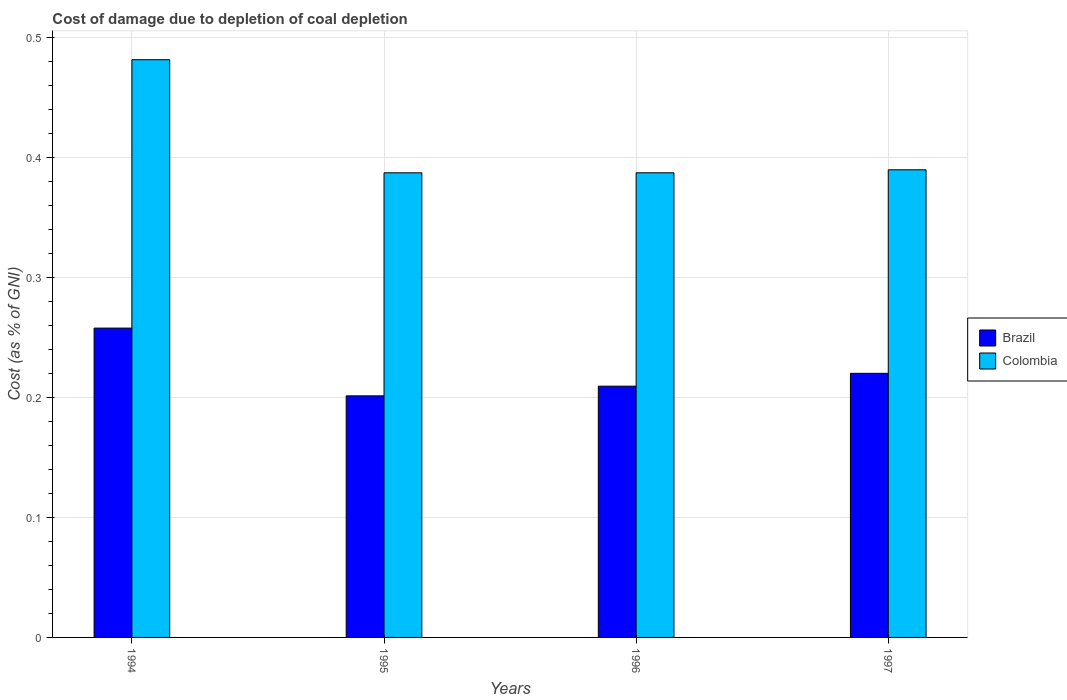How many groups of bars are there?
Your answer should be very brief. 4. Are the number of bars per tick equal to the number of legend labels?
Give a very brief answer. Yes. How many bars are there on the 4th tick from the left?
Provide a succinct answer. 2. How many bars are there on the 3rd tick from the right?
Provide a succinct answer. 2. What is the label of the 4th group of bars from the left?
Give a very brief answer. 1997. What is the cost of damage caused due to coal depletion in Colombia in 1995?
Your response must be concise. 0.39. Across all years, what is the maximum cost of damage caused due to coal depletion in Colombia?
Your answer should be very brief. 0.48. Across all years, what is the minimum cost of damage caused due to coal depletion in Brazil?
Give a very brief answer. 0.2. In which year was the cost of damage caused due to coal depletion in Colombia minimum?
Provide a short and direct response. 1995. What is the total cost of damage caused due to coal depletion in Colombia in the graph?
Keep it short and to the point. 1.65. What is the difference between the cost of damage caused due to coal depletion in Brazil in 1994 and that in 1995?
Keep it short and to the point. 0.06. What is the difference between the cost of damage caused due to coal depletion in Colombia in 1997 and the cost of damage caused due to coal depletion in Brazil in 1994?
Ensure brevity in your answer.  0.13. What is the average cost of damage caused due to coal depletion in Brazil per year?
Make the answer very short. 0.22. In the year 1994, what is the difference between the cost of damage caused due to coal depletion in Colombia and cost of damage caused due to coal depletion in Brazil?
Your answer should be very brief. 0.22. In how many years, is the cost of damage caused due to coal depletion in Brazil greater than 0.42000000000000004 %?
Offer a very short reply. 0. What is the ratio of the cost of damage caused due to coal depletion in Brazil in 1996 to that in 1997?
Keep it short and to the point. 0.95. Is the cost of damage caused due to coal depletion in Colombia in 1994 less than that in 1996?
Your answer should be very brief. No. What is the difference between the highest and the second highest cost of damage caused due to coal depletion in Brazil?
Make the answer very short. 0.04. What is the difference between the highest and the lowest cost of damage caused due to coal depletion in Brazil?
Your answer should be very brief. 0.06. In how many years, is the cost of damage caused due to coal depletion in Colombia greater than the average cost of damage caused due to coal depletion in Colombia taken over all years?
Provide a succinct answer. 1. Is the sum of the cost of damage caused due to coal depletion in Colombia in 1995 and 1997 greater than the maximum cost of damage caused due to coal depletion in Brazil across all years?
Give a very brief answer. Yes. How many bars are there?
Provide a short and direct response. 8. Are all the bars in the graph horizontal?
Offer a terse response. No. How many years are there in the graph?
Your answer should be very brief. 4. Are the values on the major ticks of Y-axis written in scientific E-notation?
Keep it short and to the point. No. Does the graph contain any zero values?
Ensure brevity in your answer.  No. Does the graph contain grids?
Your answer should be compact. Yes. What is the title of the graph?
Your answer should be compact. Cost of damage due to depletion of coal depletion. What is the label or title of the Y-axis?
Ensure brevity in your answer.  Cost (as % of GNI). What is the Cost (as % of GNI) of Brazil in 1994?
Your answer should be compact. 0.26. What is the Cost (as % of GNI) in Colombia in 1994?
Your response must be concise. 0.48. What is the Cost (as % of GNI) of Brazil in 1995?
Offer a terse response. 0.2. What is the Cost (as % of GNI) in Colombia in 1995?
Provide a short and direct response. 0.39. What is the Cost (as % of GNI) of Brazil in 1996?
Provide a short and direct response. 0.21. What is the Cost (as % of GNI) of Colombia in 1996?
Provide a short and direct response. 0.39. What is the Cost (as % of GNI) in Brazil in 1997?
Make the answer very short. 0.22. What is the Cost (as % of GNI) of Colombia in 1997?
Offer a very short reply. 0.39. Across all years, what is the maximum Cost (as % of GNI) of Brazil?
Provide a succinct answer. 0.26. Across all years, what is the maximum Cost (as % of GNI) of Colombia?
Give a very brief answer. 0.48. Across all years, what is the minimum Cost (as % of GNI) in Brazil?
Your response must be concise. 0.2. Across all years, what is the minimum Cost (as % of GNI) of Colombia?
Offer a terse response. 0.39. What is the total Cost (as % of GNI) in Brazil in the graph?
Offer a very short reply. 0.89. What is the total Cost (as % of GNI) in Colombia in the graph?
Keep it short and to the point. 1.65. What is the difference between the Cost (as % of GNI) in Brazil in 1994 and that in 1995?
Give a very brief answer. 0.06. What is the difference between the Cost (as % of GNI) of Colombia in 1994 and that in 1995?
Your answer should be compact. 0.09. What is the difference between the Cost (as % of GNI) of Brazil in 1994 and that in 1996?
Give a very brief answer. 0.05. What is the difference between the Cost (as % of GNI) of Colombia in 1994 and that in 1996?
Ensure brevity in your answer.  0.09. What is the difference between the Cost (as % of GNI) in Brazil in 1994 and that in 1997?
Give a very brief answer. 0.04. What is the difference between the Cost (as % of GNI) in Colombia in 1994 and that in 1997?
Offer a terse response. 0.09. What is the difference between the Cost (as % of GNI) in Brazil in 1995 and that in 1996?
Offer a terse response. -0.01. What is the difference between the Cost (as % of GNI) in Colombia in 1995 and that in 1996?
Give a very brief answer. -0. What is the difference between the Cost (as % of GNI) in Brazil in 1995 and that in 1997?
Your answer should be compact. -0.02. What is the difference between the Cost (as % of GNI) of Colombia in 1995 and that in 1997?
Provide a succinct answer. -0. What is the difference between the Cost (as % of GNI) of Brazil in 1996 and that in 1997?
Make the answer very short. -0.01. What is the difference between the Cost (as % of GNI) of Colombia in 1996 and that in 1997?
Your answer should be very brief. -0. What is the difference between the Cost (as % of GNI) in Brazil in 1994 and the Cost (as % of GNI) in Colombia in 1995?
Offer a terse response. -0.13. What is the difference between the Cost (as % of GNI) in Brazil in 1994 and the Cost (as % of GNI) in Colombia in 1996?
Provide a succinct answer. -0.13. What is the difference between the Cost (as % of GNI) in Brazil in 1994 and the Cost (as % of GNI) in Colombia in 1997?
Keep it short and to the point. -0.13. What is the difference between the Cost (as % of GNI) of Brazil in 1995 and the Cost (as % of GNI) of Colombia in 1996?
Your answer should be compact. -0.19. What is the difference between the Cost (as % of GNI) of Brazil in 1995 and the Cost (as % of GNI) of Colombia in 1997?
Offer a terse response. -0.19. What is the difference between the Cost (as % of GNI) in Brazil in 1996 and the Cost (as % of GNI) in Colombia in 1997?
Offer a very short reply. -0.18. What is the average Cost (as % of GNI) in Brazil per year?
Your response must be concise. 0.22. What is the average Cost (as % of GNI) of Colombia per year?
Provide a succinct answer. 0.41. In the year 1994, what is the difference between the Cost (as % of GNI) of Brazil and Cost (as % of GNI) of Colombia?
Provide a short and direct response. -0.22. In the year 1995, what is the difference between the Cost (as % of GNI) in Brazil and Cost (as % of GNI) in Colombia?
Your response must be concise. -0.19. In the year 1996, what is the difference between the Cost (as % of GNI) of Brazil and Cost (as % of GNI) of Colombia?
Give a very brief answer. -0.18. In the year 1997, what is the difference between the Cost (as % of GNI) of Brazil and Cost (as % of GNI) of Colombia?
Offer a very short reply. -0.17. What is the ratio of the Cost (as % of GNI) of Brazil in 1994 to that in 1995?
Your response must be concise. 1.28. What is the ratio of the Cost (as % of GNI) of Colombia in 1994 to that in 1995?
Your answer should be very brief. 1.24. What is the ratio of the Cost (as % of GNI) of Brazil in 1994 to that in 1996?
Offer a terse response. 1.23. What is the ratio of the Cost (as % of GNI) of Colombia in 1994 to that in 1996?
Provide a short and direct response. 1.24. What is the ratio of the Cost (as % of GNI) in Brazil in 1994 to that in 1997?
Ensure brevity in your answer.  1.17. What is the ratio of the Cost (as % of GNI) in Colombia in 1994 to that in 1997?
Your response must be concise. 1.24. What is the ratio of the Cost (as % of GNI) in Brazil in 1995 to that in 1996?
Provide a succinct answer. 0.96. What is the ratio of the Cost (as % of GNI) in Colombia in 1995 to that in 1996?
Your response must be concise. 1. What is the ratio of the Cost (as % of GNI) in Brazil in 1995 to that in 1997?
Keep it short and to the point. 0.91. What is the ratio of the Cost (as % of GNI) in Colombia in 1995 to that in 1997?
Keep it short and to the point. 0.99. What is the ratio of the Cost (as % of GNI) of Brazil in 1996 to that in 1997?
Ensure brevity in your answer.  0.95. What is the ratio of the Cost (as % of GNI) of Colombia in 1996 to that in 1997?
Ensure brevity in your answer.  0.99. What is the difference between the highest and the second highest Cost (as % of GNI) of Brazil?
Your answer should be compact. 0.04. What is the difference between the highest and the second highest Cost (as % of GNI) of Colombia?
Give a very brief answer. 0.09. What is the difference between the highest and the lowest Cost (as % of GNI) of Brazil?
Keep it short and to the point. 0.06. What is the difference between the highest and the lowest Cost (as % of GNI) of Colombia?
Your response must be concise. 0.09. 